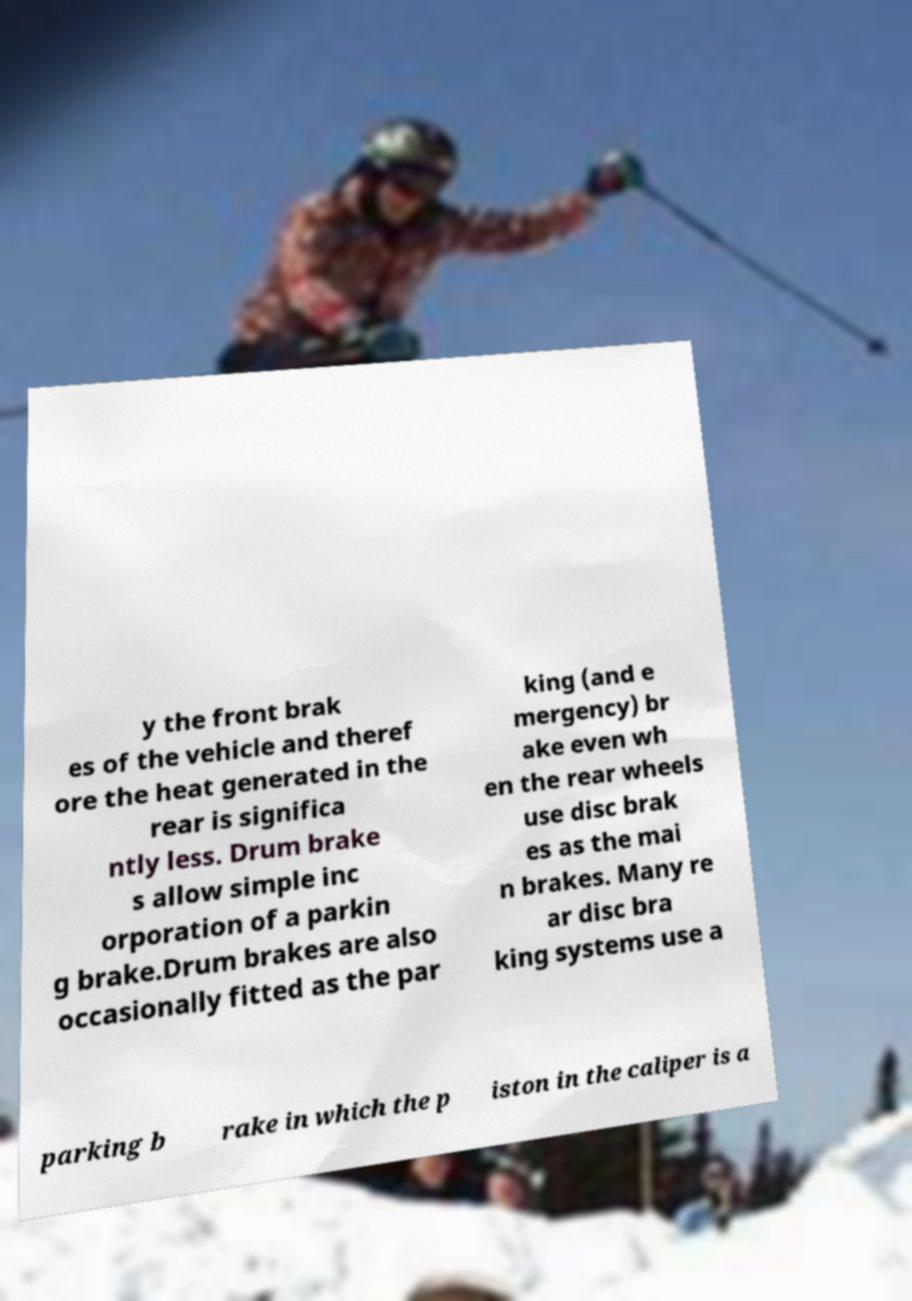Can you accurately transcribe the text from the provided image for me? y the front brak es of the vehicle and theref ore the heat generated in the rear is significa ntly less. Drum brake s allow simple inc orporation of a parkin g brake.Drum brakes are also occasionally fitted as the par king (and e mergency) br ake even wh en the rear wheels use disc brak es as the mai n brakes. Many re ar disc bra king systems use a parking b rake in which the p iston in the caliper is a 